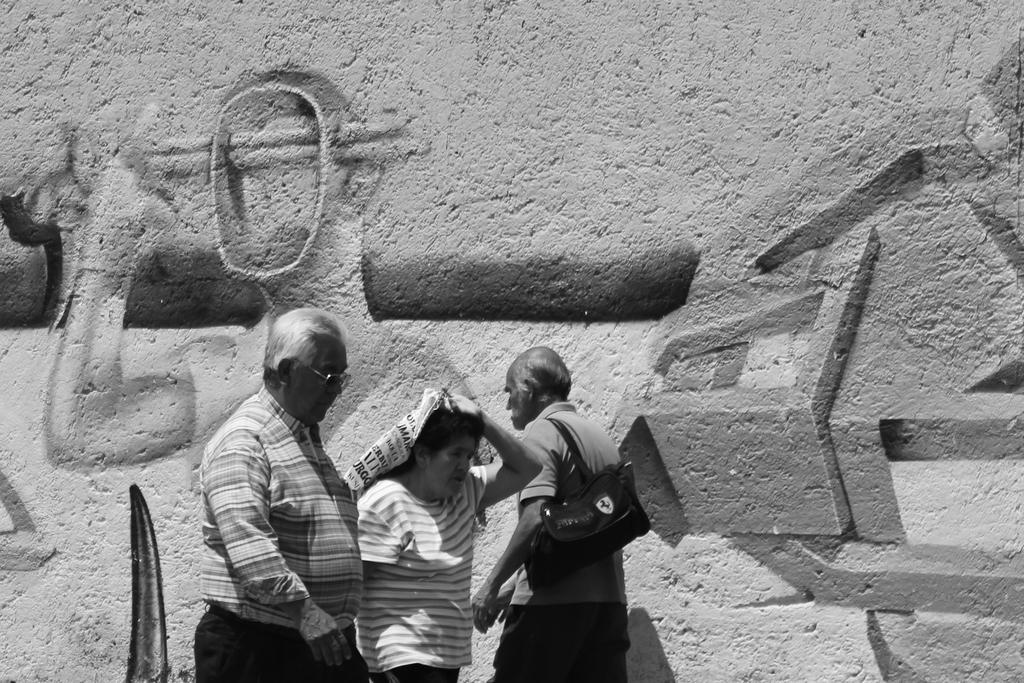What is the color scheme of the image? The image is black and white. What are the three persons in the foreground doing? They are walking in the foreground. What is the weather like in the image? It is sunny in the image. What can be seen in the background of the image? There is a wall with different pictures in the background. How many horses can be seen in the image? There are no horses present in the image. Is there a lift visible in the image? There is no lift present in the image. 